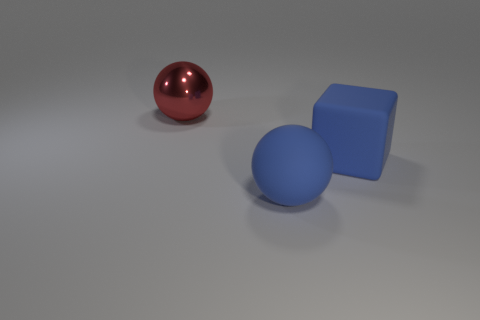What materials seem to be represented by the objects in the image? The objects in the image appear to be made of different materials. The red sphere looks like it could be a polished metal due to its reflective surface. The blue object has a solid, non-reflective appearance, perhaps resembling plastic or painted wood. Finally, the matte sphere has a diffused surface, suggesting it could be made of a substance like ceramic or unpolished stone. 